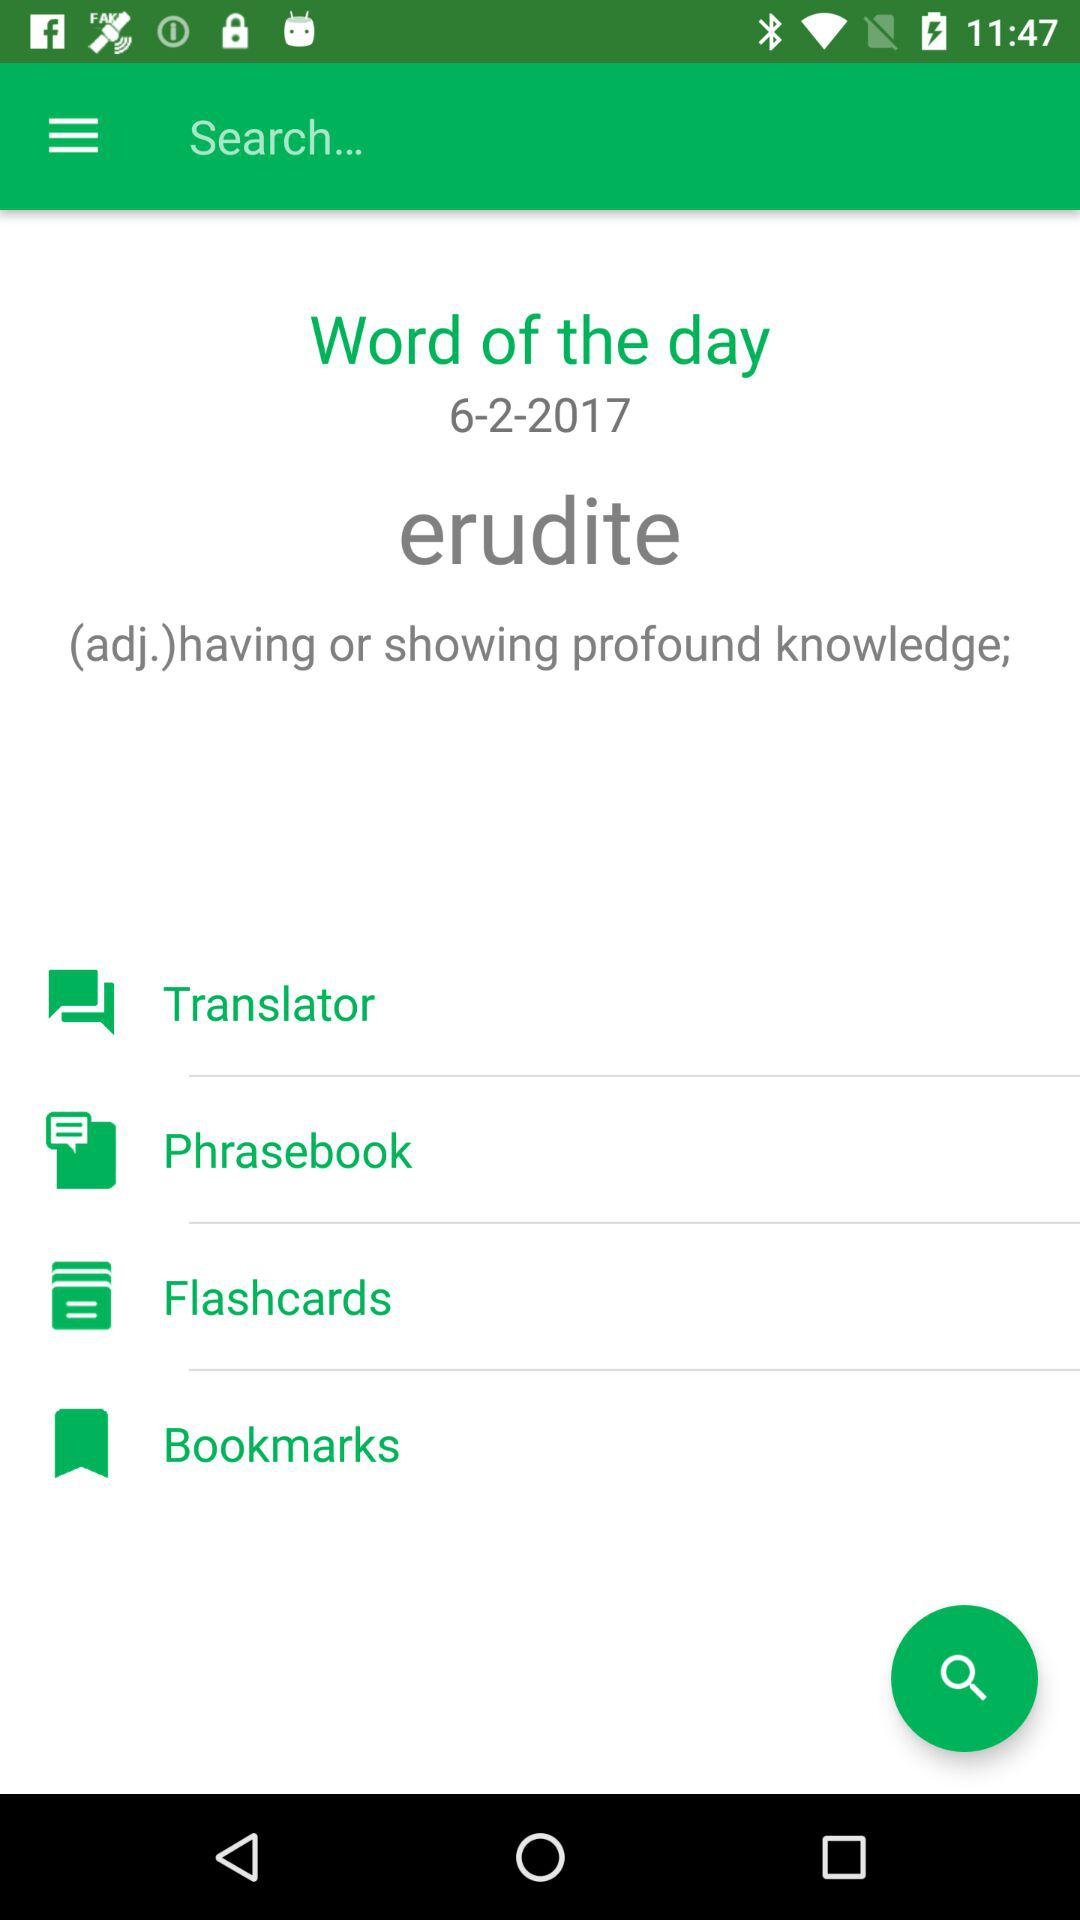What is the word of the day? The word of the day is "erudite". 